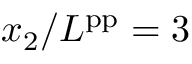Convert formula to latex. <formula><loc_0><loc_0><loc_500><loc_500>x _ { 2 } / L ^ { p p } = 3</formula> 